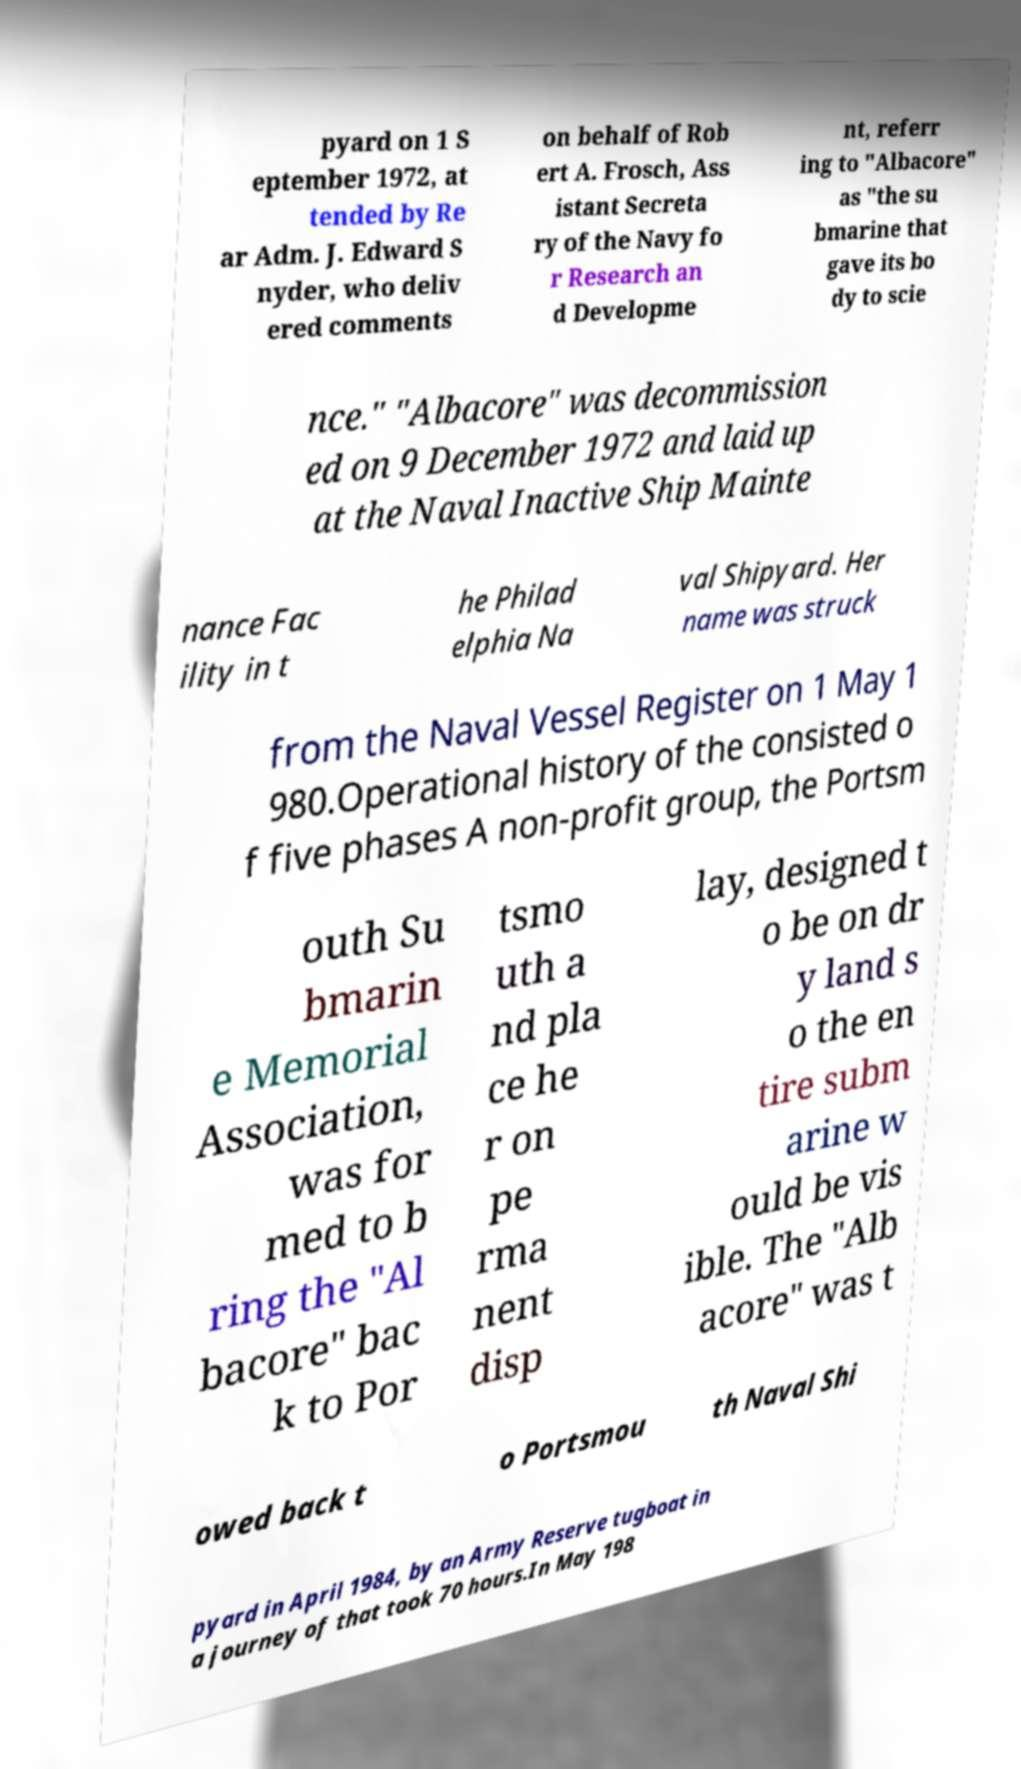For documentation purposes, I need the text within this image transcribed. Could you provide that? pyard on 1 S eptember 1972, at tended by Re ar Adm. J. Edward S nyder, who deliv ered comments on behalf of Rob ert A. Frosch, Ass istant Secreta ry of the Navy fo r Research an d Developme nt, referr ing to "Albacore" as "the su bmarine that gave its bo dy to scie nce." "Albacore" was decommission ed on 9 December 1972 and laid up at the Naval Inactive Ship Mainte nance Fac ility in t he Philad elphia Na val Shipyard. Her name was struck from the Naval Vessel Register on 1 May 1 980.Operational history of the consisted o f five phases A non-profit group, the Portsm outh Su bmarin e Memorial Association, was for med to b ring the "Al bacore" bac k to Por tsmo uth a nd pla ce he r on pe rma nent disp lay, designed t o be on dr y land s o the en tire subm arine w ould be vis ible. The "Alb acore" was t owed back t o Portsmou th Naval Shi pyard in April 1984, by an Army Reserve tugboat in a journey of that took 70 hours.In May 198 